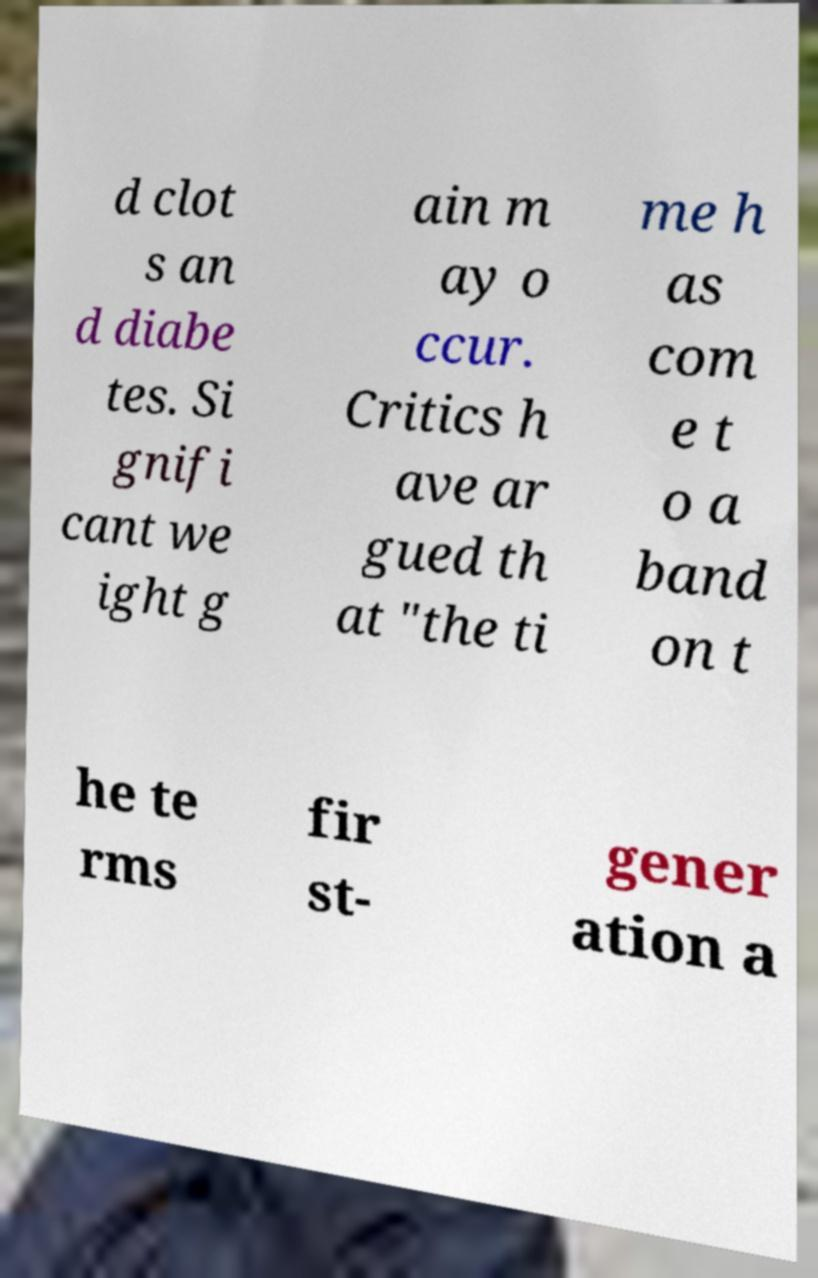For documentation purposes, I need the text within this image transcribed. Could you provide that? d clot s an d diabe tes. Si gnifi cant we ight g ain m ay o ccur. Critics h ave ar gued th at "the ti me h as com e t o a band on t he te rms fir st- gener ation a 